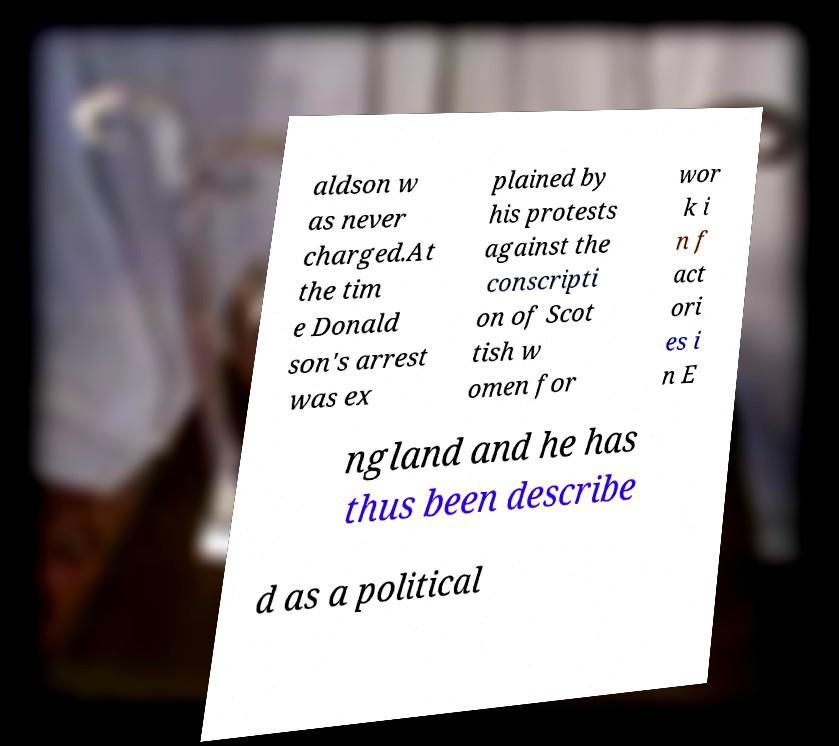There's text embedded in this image that I need extracted. Can you transcribe it verbatim? aldson w as never charged.At the tim e Donald son's arrest was ex plained by his protests against the conscripti on of Scot tish w omen for wor k i n f act ori es i n E ngland and he has thus been describe d as a political 